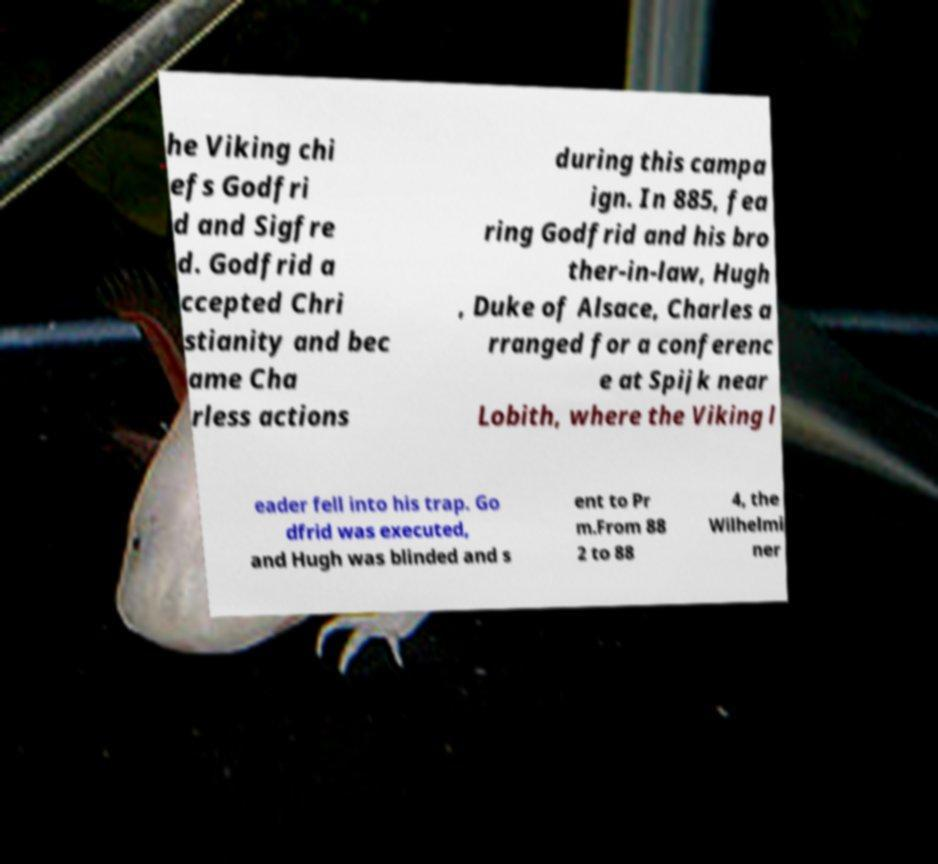I need the written content from this picture converted into text. Can you do that? he Viking chi efs Godfri d and Sigfre d. Godfrid a ccepted Chri stianity and bec ame Cha rless actions during this campa ign. In 885, fea ring Godfrid and his bro ther-in-law, Hugh , Duke of Alsace, Charles a rranged for a conferenc e at Spijk near Lobith, where the Viking l eader fell into his trap. Go dfrid was executed, and Hugh was blinded and s ent to Pr m.From 88 2 to 88 4, the Wilhelmi ner 